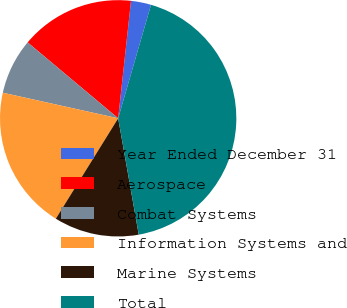<chart> <loc_0><loc_0><loc_500><loc_500><pie_chart><fcel>Year Ended December 31<fcel>Aerospace<fcel>Combat Systems<fcel>Information Systems and<fcel>Marine Systems<fcel>Total<nl><fcel>2.75%<fcel>15.63%<fcel>7.63%<fcel>19.63%<fcel>11.63%<fcel>42.73%<nl></chart> 